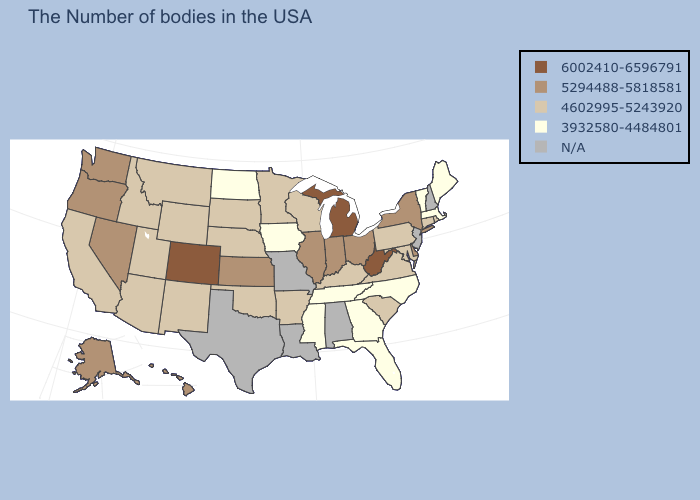Does North Carolina have the highest value in the USA?
Answer briefly. No. Which states have the highest value in the USA?
Answer briefly. West Virginia, Michigan, Colorado. What is the lowest value in the West?
Concise answer only. 4602995-5243920. Which states have the highest value in the USA?
Concise answer only. West Virginia, Michigan, Colorado. What is the lowest value in the USA?
Give a very brief answer. 3932580-4484801. Does the first symbol in the legend represent the smallest category?
Concise answer only. No. What is the highest value in the USA?
Answer briefly. 6002410-6596791. Name the states that have a value in the range 3932580-4484801?
Quick response, please. Maine, Massachusetts, Vermont, North Carolina, Florida, Georgia, Tennessee, Mississippi, Iowa, North Dakota. Name the states that have a value in the range 4602995-5243920?
Give a very brief answer. Rhode Island, Connecticut, Maryland, Pennsylvania, Virginia, South Carolina, Kentucky, Wisconsin, Arkansas, Minnesota, Nebraska, Oklahoma, South Dakota, Wyoming, New Mexico, Utah, Montana, Arizona, Idaho, California. Among the states that border Oklahoma , which have the lowest value?
Be succinct. Arkansas, New Mexico. Does West Virginia have the highest value in the South?
Keep it brief. Yes. What is the value of Massachusetts?
Short answer required. 3932580-4484801. Does Florida have the highest value in the South?
Write a very short answer. No. 